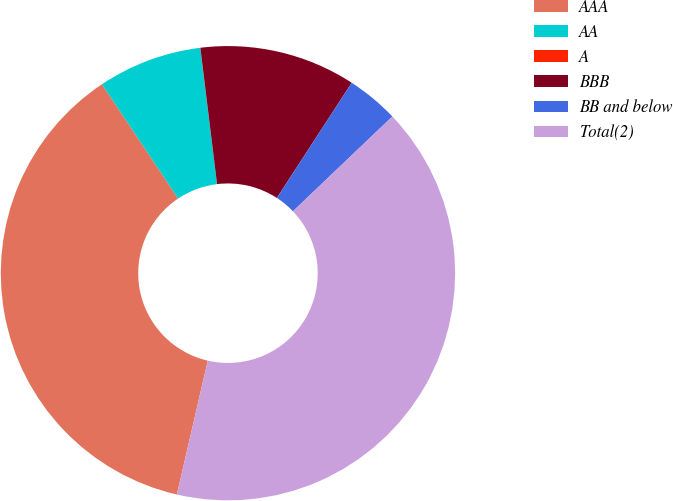<chart> <loc_0><loc_0><loc_500><loc_500><pie_chart><fcel>AAA<fcel>AA<fcel>A<fcel>BBB<fcel>BB and below<fcel>Total(2)<nl><fcel>37.03%<fcel>7.41%<fcel>0.01%<fcel>11.11%<fcel>3.71%<fcel>40.73%<nl></chart> 